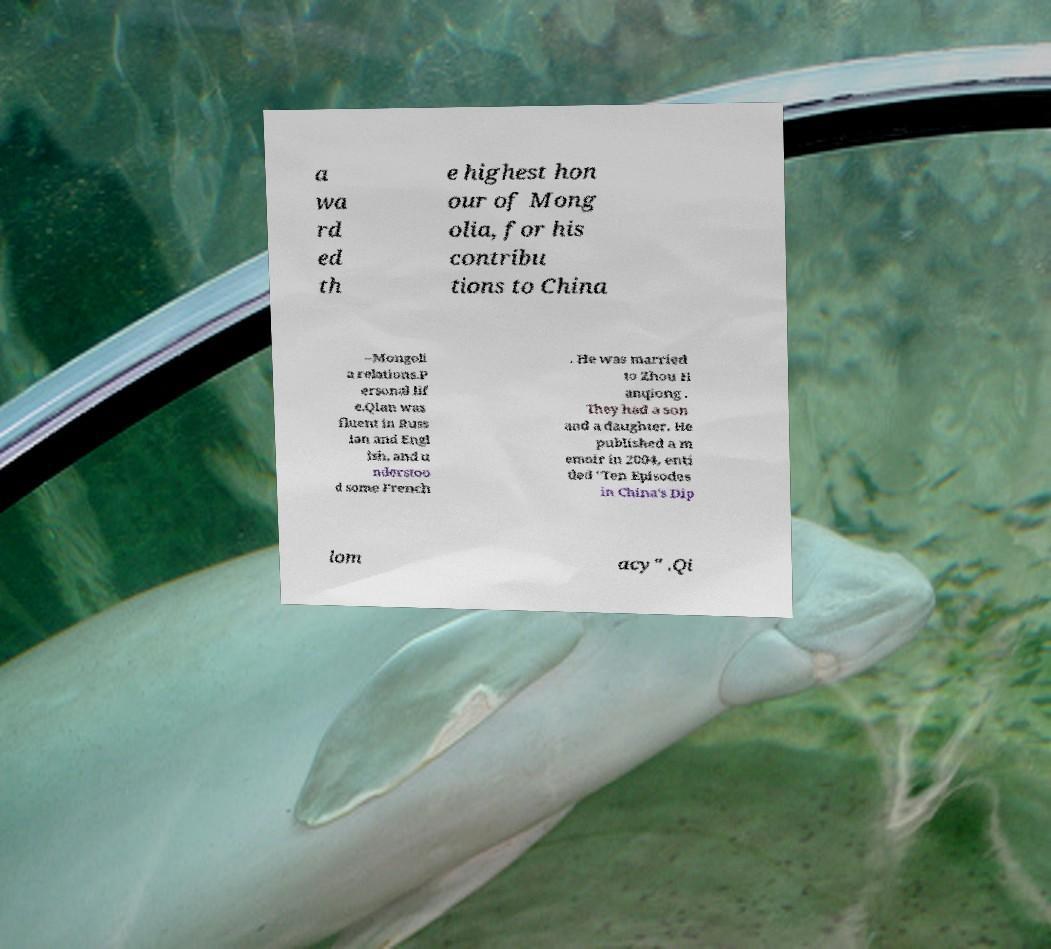Please read and relay the text visible in this image. What does it say? a wa rd ed th e highest hon our of Mong olia, for his contribu tions to China –Mongoli a relations.P ersonal lif e.Qian was fluent in Russ ian and Engl ish, and u nderstoo d some French . He was married to Zhou H anqiong . They had a son and a daughter. He published a m emoir in 2004, enti tled "Ten Episodes in China's Dip lom acy" .Qi 